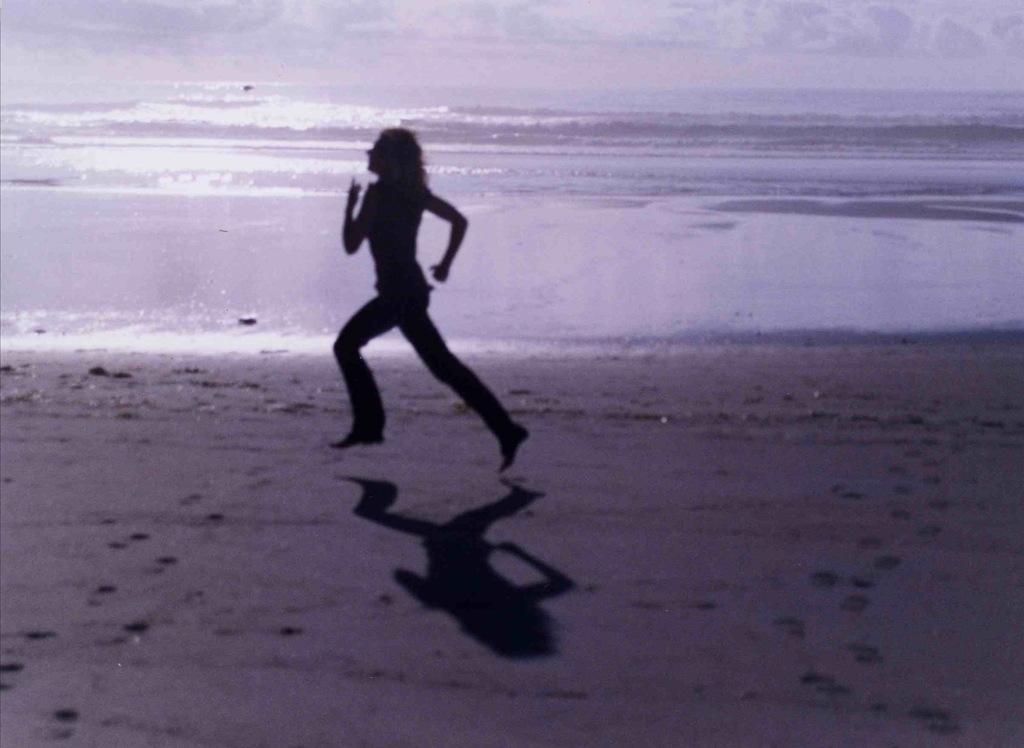Can you describe this image briefly? In this image we can see a woman is running on the ground, there is the water. 